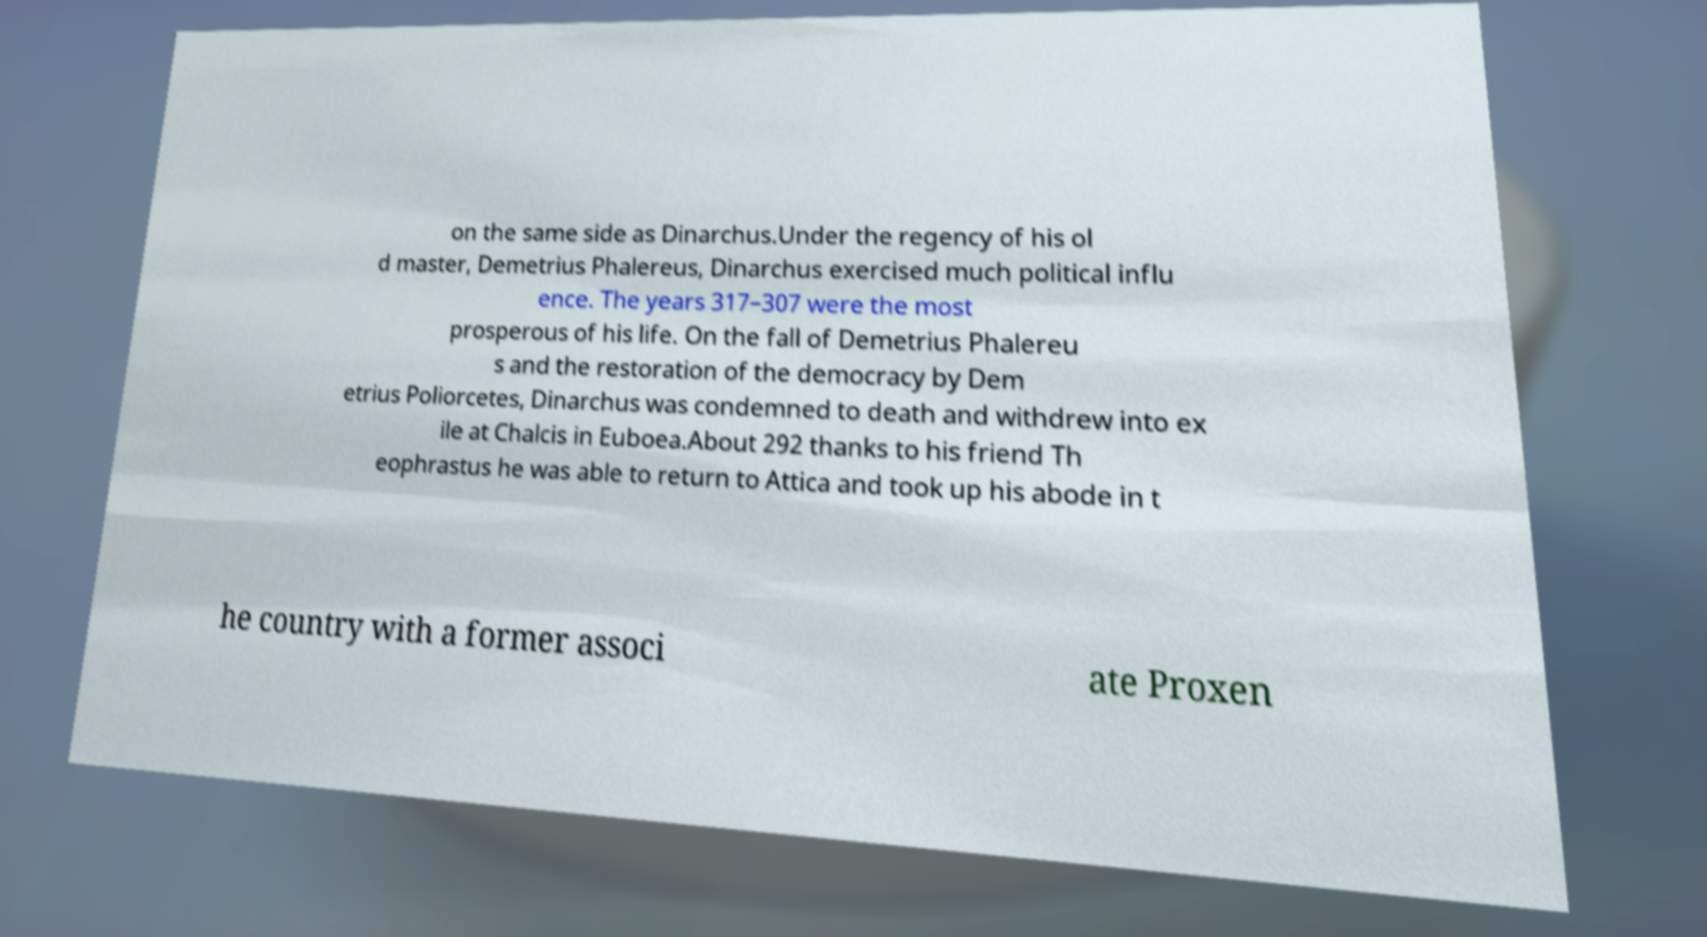For documentation purposes, I need the text within this image transcribed. Could you provide that? on the same side as Dinarchus.Under the regency of his ol d master, Demetrius Phalereus, Dinarchus exercised much political influ ence. The years 317–307 were the most prosperous of his life. On the fall of Demetrius Phalereu s and the restoration of the democracy by Dem etrius Poliorcetes, Dinarchus was condemned to death and withdrew into ex ile at Chalcis in Euboea.About 292 thanks to his friend Th eophrastus he was able to return to Attica and took up his abode in t he country with a former associ ate Proxen 